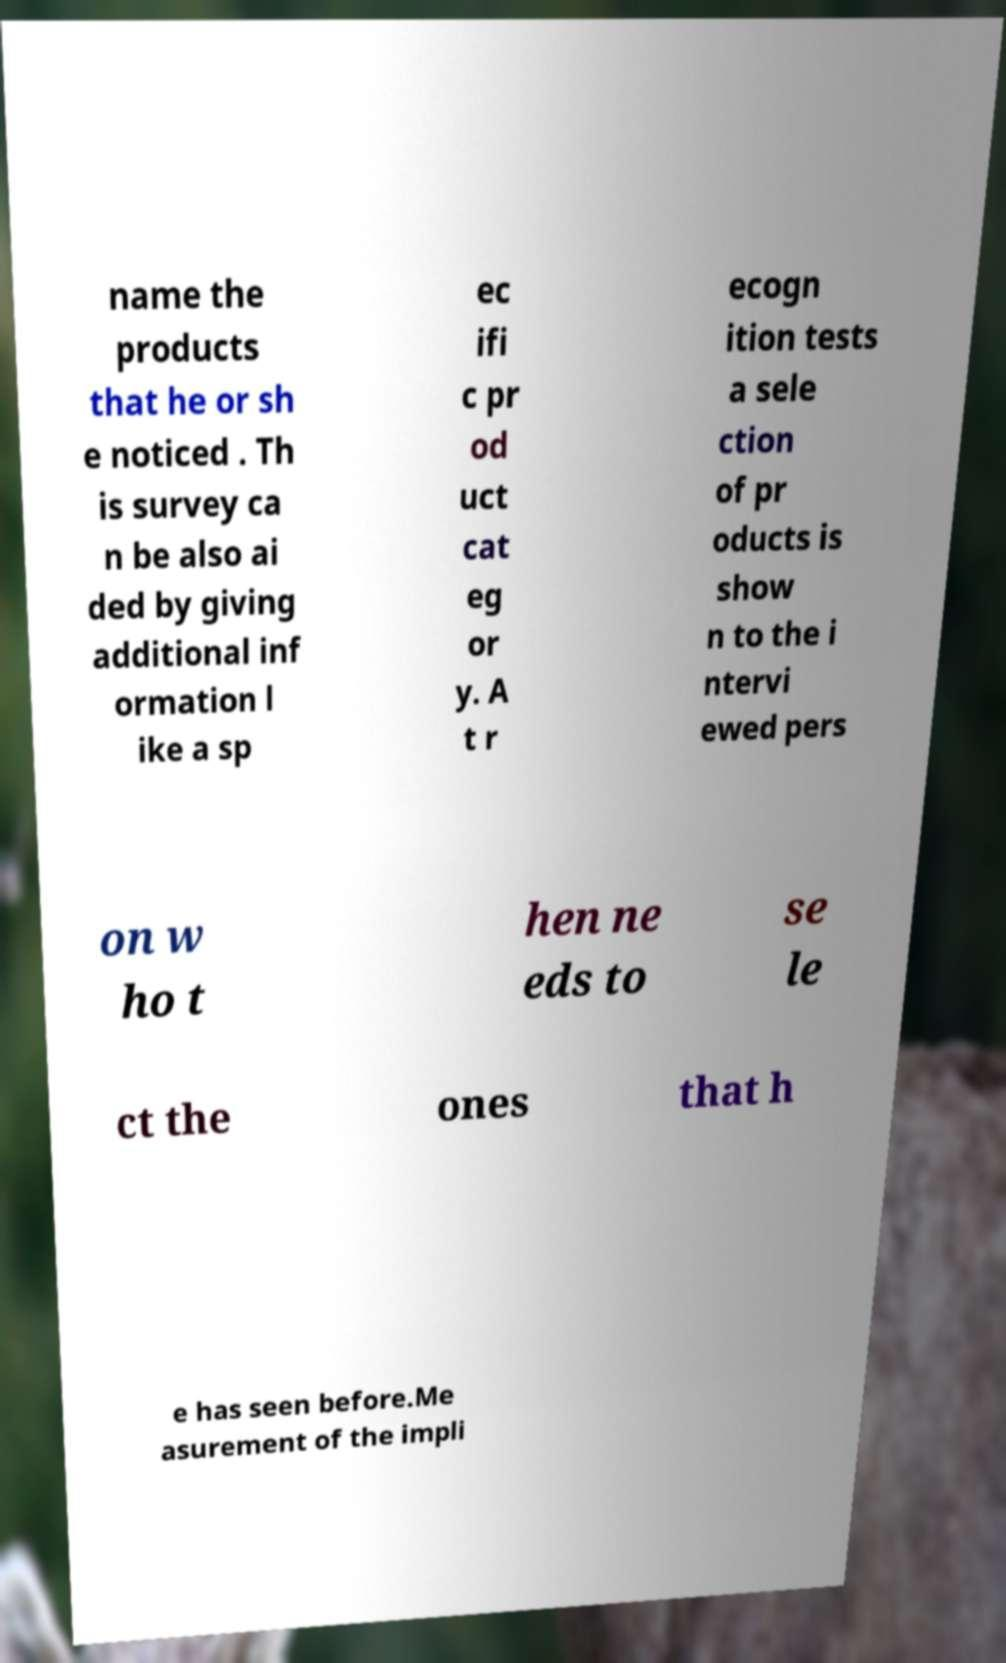For documentation purposes, I need the text within this image transcribed. Could you provide that? name the products that he or sh e noticed . Th is survey ca n be also ai ded by giving additional inf ormation l ike a sp ec ifi c pr od uct cat eg or y. A t r ecogn ition tests a sele ction of pr oducts is show n to the i ntervi ewed pers on w ho t hen ne eds to se le ct the ones that h e has seen before.Me asurement of the impli 